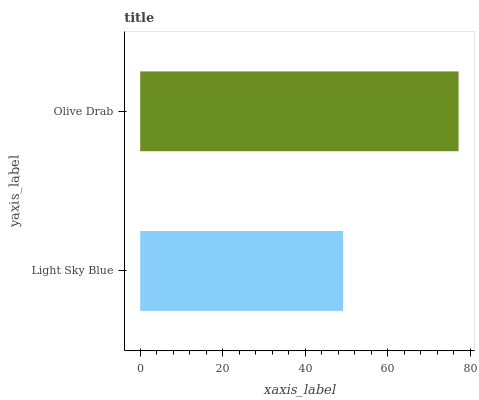Is Light Sky Blue the minimum?
Answer yes or no. Yes. Is Olive Drab the maximum?
Answer yes or no. Yes. Is Olive Drab the minimum?
Answer yes or no. No. Is Olive Drab greater than Light Sky Blue?
Answer yes or no. Yes. Is Light Sky Blue less than Olive Drab?
Answer yes or no. Yes. Is Light Sky Blue greater than Olive Drab?
Answer yes or no. No. Is Olive Drab less than Light Sky Blue?
Answer yes or no. No. Is Olive Drab the high median?
Answer yes or no. Yes. Is Light Sky Blue the low median?
Answer yes or no. Yes. Is Light Sky Blue the high median?
Answer yes or no. No. Is Olive Drab the low median?
Answer yes or no. No. 